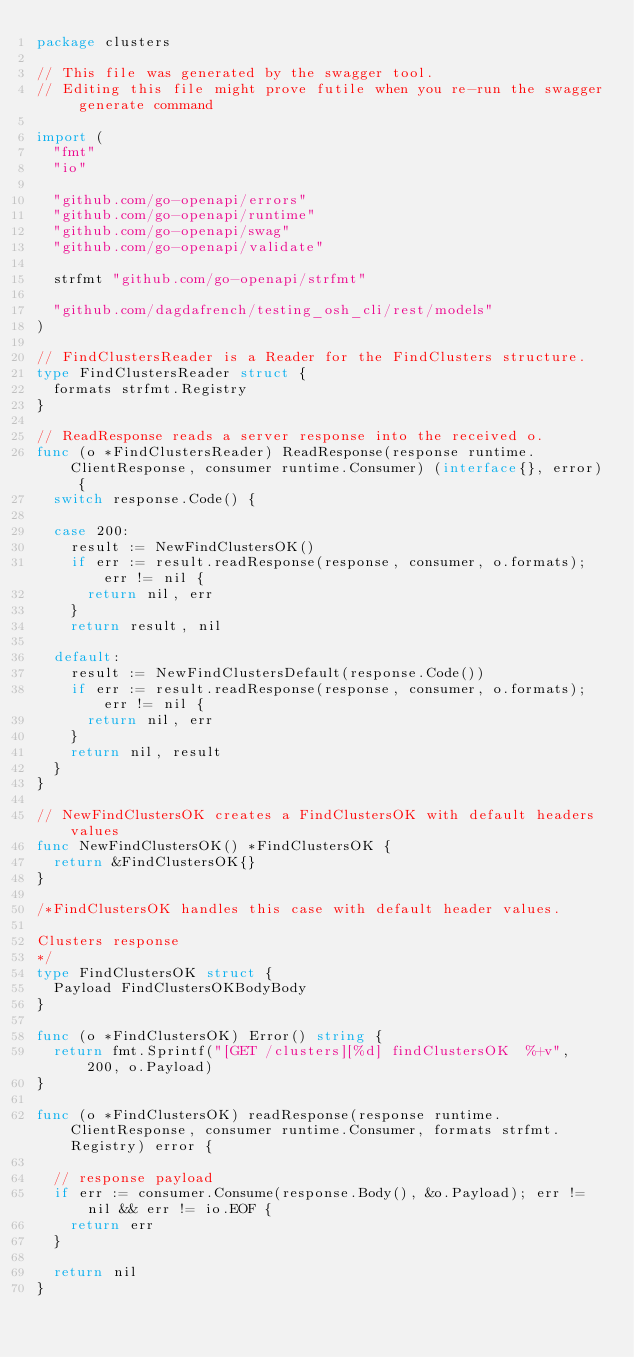Convert code to text. <code><loc_0><loc_0><loc_500><loc_500><_Go_>package clusters

// This file was generated by the swagger tool.
// Editing this file might prove futile when you re-run the swagger generate command

import (
	"fmt"
	"io"

	"github.com/go-openapi/errors"
	"github.com/go-openapi/runtime"
	"github.com/go-openapi/swag"
	"github.com/go-openapi/validate"

	strfmt "github.com/go-openapi/strfmt"

	"github.com/dagdafrench/testing_osh_cli/rest/models"
)

// FindClustersReader is a Reader for the FindClusters structure.
type FindClustersReader struct {
	formats strfmt.Registry
}

// ReadResponse reads a server response into the received o.
func (o *FindClustersReader) ReadResponse(response runtime.ClientResponse, consumer runtime.Consumer) (interface{}, error) {
	switch response.Code() {

	case 200:
		result := NewFindClustersOK()
		if err := result.readResponse(response, consumer, o.formats); err != nil {
			return nil, err
		}
		return result, nil

	default:
		result := NewFindClustersDefault(response.Code())
		if err := result.readResponse(response, consumer, o.formats); err != nil {
			return nil, err
		}
		return nil, result
	}
}

// NewFindClustersOK creates a FindClustersOK with default headers values
func NewFindClustersOK() *FindClustersOK {
	return &FindClustersOK{}
}

/*FindClustersOK handles this case with default header values.

Clusters response
*/
type FindClustersOK struct {
	Payload FindClustersOKBodyBody
}

func (o *FindClustersOK) Error() string {
	return fmt.Sprintf("[GET /clusters][%d] findClustersOK  %+v", 200, o.Payload)
}

func (o *FindClustersOK) readResponse(response runtime.ClientResponse, consumer runtime.Consumer, formats strfmt.Registry) error {

	// response payload
	if err := consumer.Consume(response.Body(), &o.Payload); err != nil && err != io.EOF {
		return err
	}

	return nil
}
</code> 